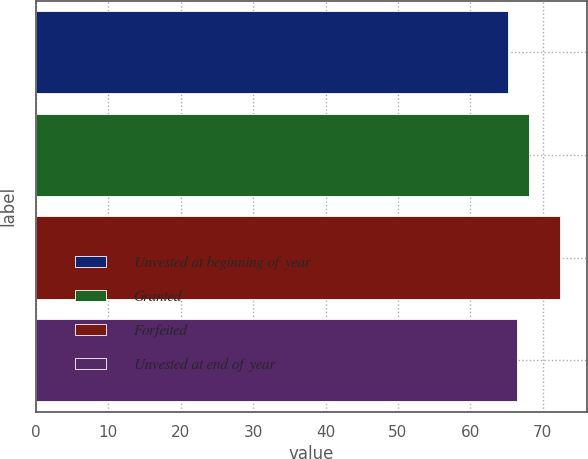Convert chart to OTSL. <chart><loc_0><loc_0><loc_500><loc_500><bar_chart><fcel>Unvested at beginning of year<fcel>Granted<fcel>Forfeited<fcel>Unvested at end of year<nl><fcel>65.14<fcel>68.04<fcel>72.44<fcel>66.49<nl></chart> 